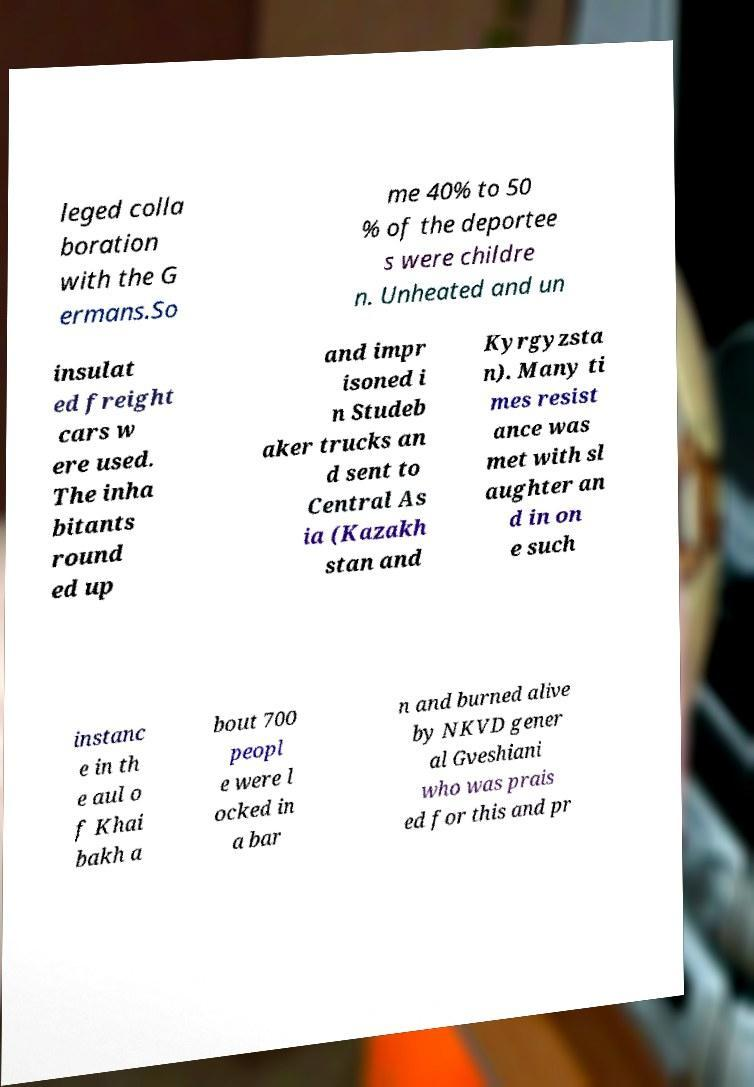Can you accurately transcribe the text from the provided image for me? leged colla boration with the G ermans.So me 40% to 50 % of the deportee s were childre n. Unheated and un insulat ed freight cars w ere used. The inha bitants round ed up and impr isoned i n Studeb aker trucks an d sent to Central As ia (Kazakh stan and Kyrgyzsta n). Many ti mes resist ance was met with sl aughter an d in on e such instanc e in th e aul o f Khai bakh a bout 700 peopl e were l ocked in a bar n and burned alive by NKVD gener al Gveshiani who was prais ed for this and pr 